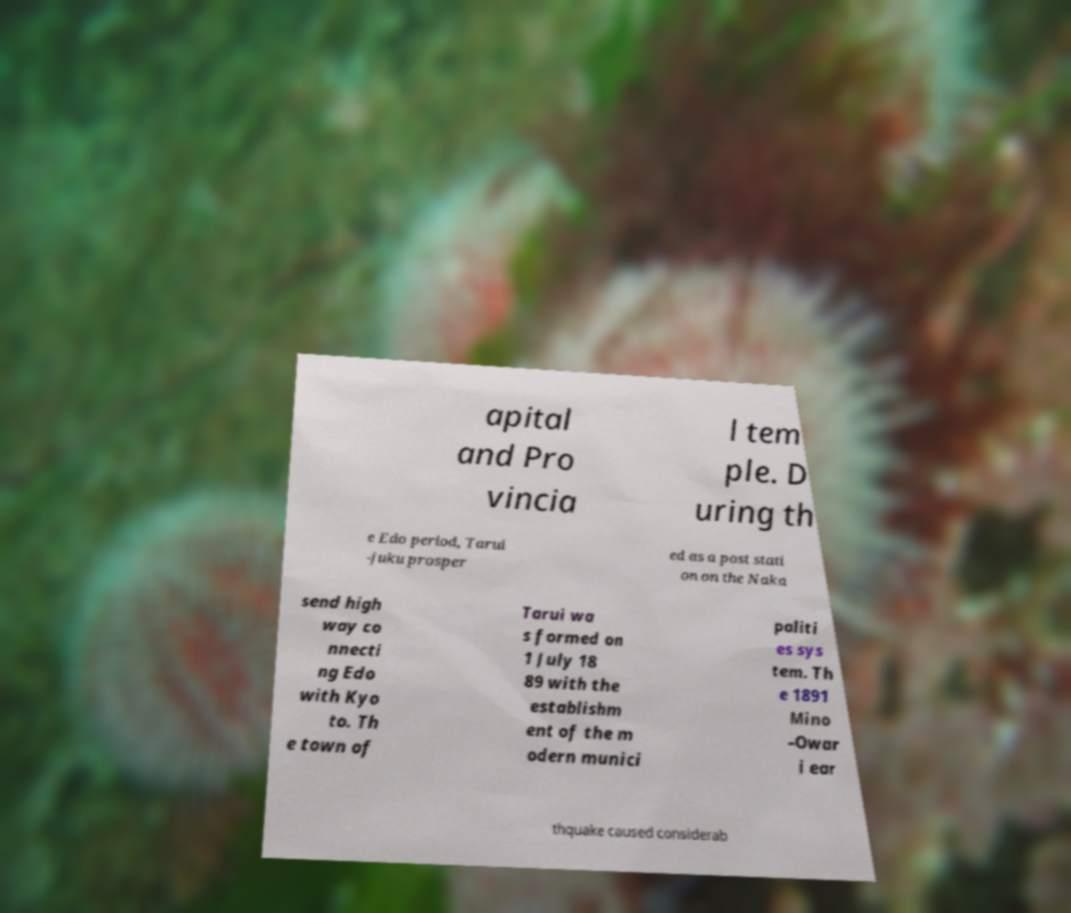Please read and relay the text visible in this image. What does it say? apital and Pro vincia l tem ple. D uring th e Edo period, Tarui -juku prosper ed as a post stati on on the Naka send high way co nnecti ng Edo with Kyo to. Th e town of Tarui wa s formed on 1 July 18 89 with the establishm ent of the m odern munici paliti es sys tem. Th e 1891 Mino –Owar i ear thquake caused considerab 